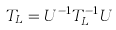Convert formula to latex. <formula><loc_0><loc_0><loc_500><loc_500>T _ { L } = U ^ { - 1 } T _ { L } ^ { - 1 } U</formula> 